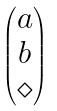<formula> <loc_0><loc_0><loc_500><loc_500>\begin{pmatrix} a \\ b \\ \diamond \end{pmatrix}</formula> 